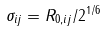Convert formula to latex. <formula><loc_0><loc_0><loc_500><loc_500>\sigma _ { i j } = R _ { 0 , i j } / 2 ^ { 1 / 6 }</formula> 